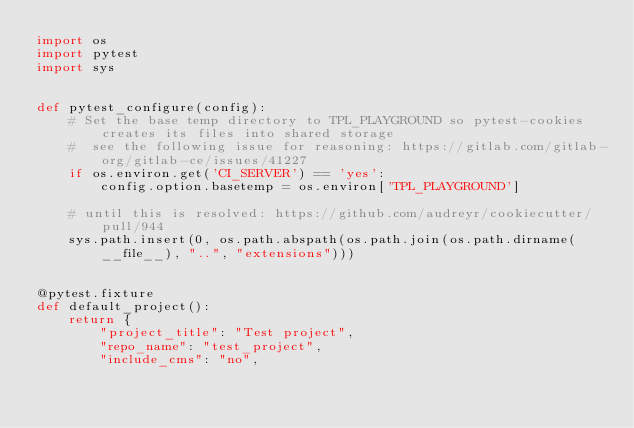Convert code to text. <code><loc_0><loc_0><loc_500><loc_500><_Python_>import os
import pytest
import sys


def pytest_configure(config):
    # Set the base temp directory to TPL_PLAYGROUND so pytest-cookies creates its files into shared storage
    #  see the following issue for reasoning: https://gitlab.com/gitlab-org/gitlab-ce/issues/41227
    if os.environ.get('CI_SERVER') == 'yes':
        config.option.basetemp = os.environ['TPL_PLAYGROUND']

    # until this is resolved: https://github.com/audreyr/cookiecutter/pull/944
    sys.path.insert(0, os.path.abspath(os.path.join(os.path.dirname(__file__), "..", "extensions")))


@pytest.fixture
def default_project():
    return {
        "project_title": "Test project",
        "repo_name": "test_project",
        "include_cms": "no",</code> 